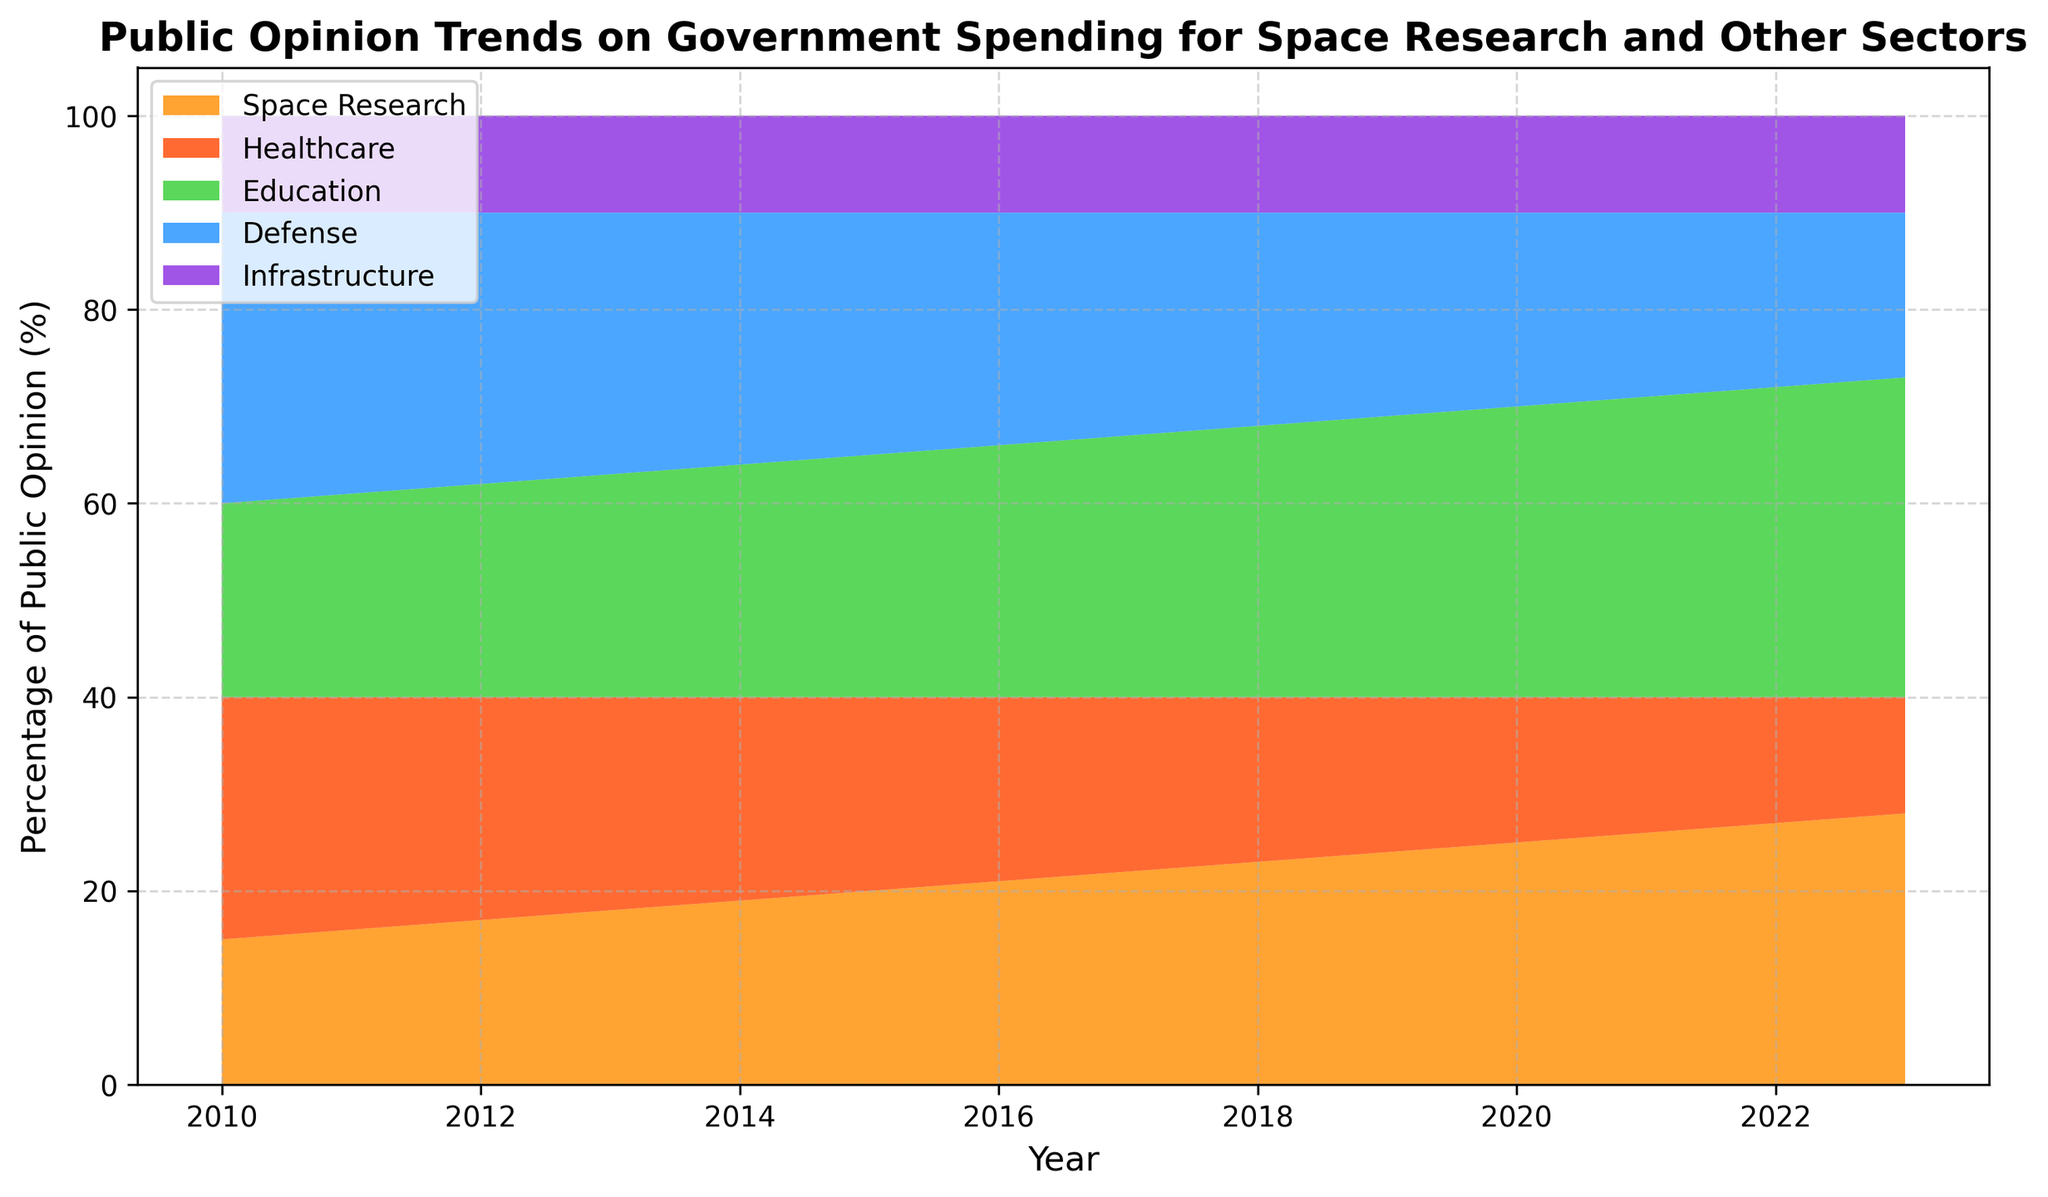what is the overall trend in public opinion on government spending for space research from 2010 to 2023? The data shows a year-on-year increase in the public's support for space research spending, starting at 15% in 2010 and rising steadily to 28% in 2023.
Answer: Increasing trend how does the trend in public opinion for healthcare spending compare with that for education spending over the years? Public opinion on healthcare spending has shown a steady decline from 25% in 2010 to 12% in 2023, while support for education spending has shown a steady increase from 20% in 2010 to 33% in 2023.
Answer: Healthcare down, Education up what is the change in percentage points for defense spending from 2010 to 2023? Defense spending public opinion starts at 30% in 2010 and declines to 17% in 2023. The change is 30% - 17% = 13 percentage points.
Answer: 13 percentage points decrease which sector had the highest public support in 2015? Looking at the chart for the year 2015, education had the highest public support with 25%.
Answer: Education how does the public opinion on infrastructure spending compare with other sectors over the years? Public opinion on infrastructure spending has remained constant at 10% throughout 2010 to 2023, while other sectors show varying trends.
Answer: Constant at 10% in which year did space research public opinion surpass healthcare public opinion? By examining the trends, space research surpassed healthcare in 2016 when space research reached 21% while healthcare was at 19%.
Answer: 2016 how much larger is the public opinion for education spending than for defense spending in 2023? In 2023, education has 33% while defense has 17%. The difference is 33% - 17% = 16 percentage points.
Answer: 16 percentage points larger what is the average public opinion for space research from 2010 to 2023? To find the average: (15 + 16 + 17 + 18 + 19 + 20 + 21 + 22 + 23 + 24 + 25 + 26 + 27 + 28) / 14 ≈ 21
Answer: 21 in which year did public opinion for space research, healthcare, and education simultaneously show a crossover? By inspecting the graph, in 2015, public opinion for space research (20%), healthcare (20%), and education (25%) show significant crossover.
Answer: 2015 